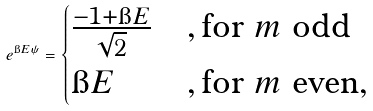<formula> <loc_0><loc_0><loc_500><loc_500>e ^ { \i E \psi } = \begin{cases} \frac { - 1 + \i E } { \sqrt { 2 } } & , \text {for } m \text { odd} \\ \i E & , \text {for } m \text { even} , \end{cases}</formula> 